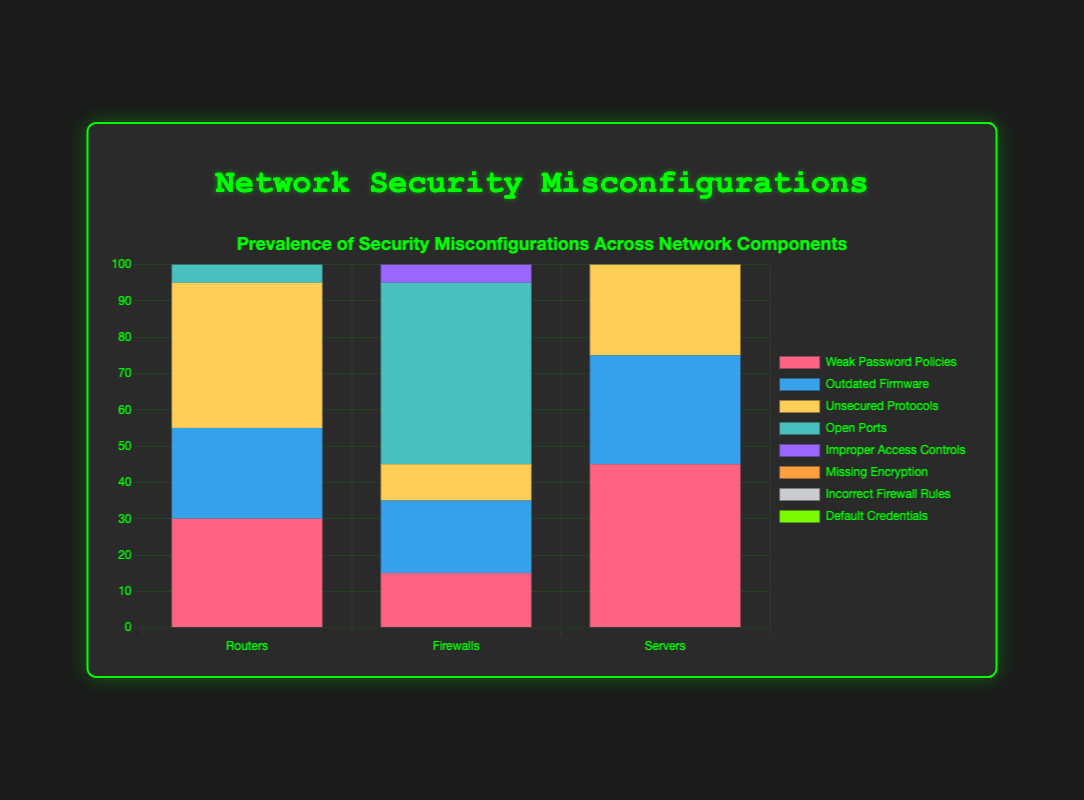Which network component has the highest prevalence of weak password policies? To determine this, look at the bars representing weak password policies (in red) for each network component. The 'Servers' bar is the highest in red.
Answer: Servers How many total open ports are there across all network components? Sum the values for open ports (identified by the teal bars) from each component: Routers (20) + Firewalls (50) + Servers (10). So, the total is 20 + 50 + 10 = 80.
Answer: 80 Which network component has the least missing encryption cases? Identify the bars representing missing encryption (orange). Firewalls have the smallest bar for missing encryption, valued at 5.
Answer: Firewalls Compare the prevalence of improper access controls between servers and firewalls. Which is higher and by how much? Check the bars for improper access controls (purple) for servers and firewalls. Servers have 50, and Firewalls have 40. The difference is 50 - 40 = 10.
Answer: Servers by 10 Which type of misconfiguration is most prevalent in routers? Identify the highest bar for routers. The tallest bar for routers is for unsecured protocols (yellow), which is 40.
Answer: Unsecured protocols What is the total number of default credentials cases across all components? Sum the values for default credentials (identified by light green bars) from each component: Routers (35) + Firewalls (10) + Servers (20). So, the total is 35 + 10 + 20 = 65.
Answer: 65 Between outdated firmware and incorrect firewall rules, which misconfiguration is more prevalent in firewalls? Compare the heights of the bars for firewalls representing outdated firmware (blue) and incorrect firewall rules (grey). Incorrect firewall rules are taller at 35, while outdated firmware is 20.
Answer: Incorrect firewall rules In which network component is the prevalence of default credentials higher than weak password policies? Compare the bars for default credentials (light green) and weak password policies (red) for each component. In routers, default credentials (35) are higher than weak password policies (30).
Answer: Routers Which has a higher prevalence in servers: missing encryption or outdated firmware? By how much? Compare the bars for servers representing missing encryption (orange) and outdated firmware (blue). Missing encryption is 30, and outdated firmware is 30. The difference is 0.
Answer: Same What is the total number of misconfigurations identified in servers? Sum the values of all misconfiguration types for servers: 45 (weak password policies) + 30 (outdated firmware) + 25 (unsecured protocols) + 10 (open ports) + 50 (improper access controls) + 30 (missing encryption) + 15 (incorrect firewall rules) + 20 (default credentials). The total is 225.
Answer: 225 